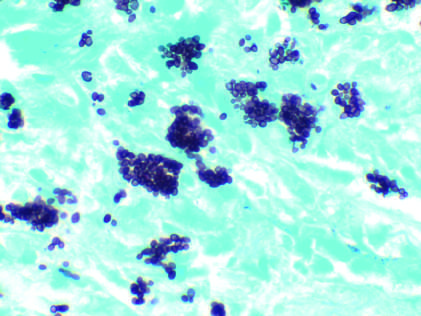what do histoplasma capsulatum yeast forms fill?
Answer the question using a single word or phrase. Phagocytes in the lymph node of a patient with disseminated histoplasmosis 